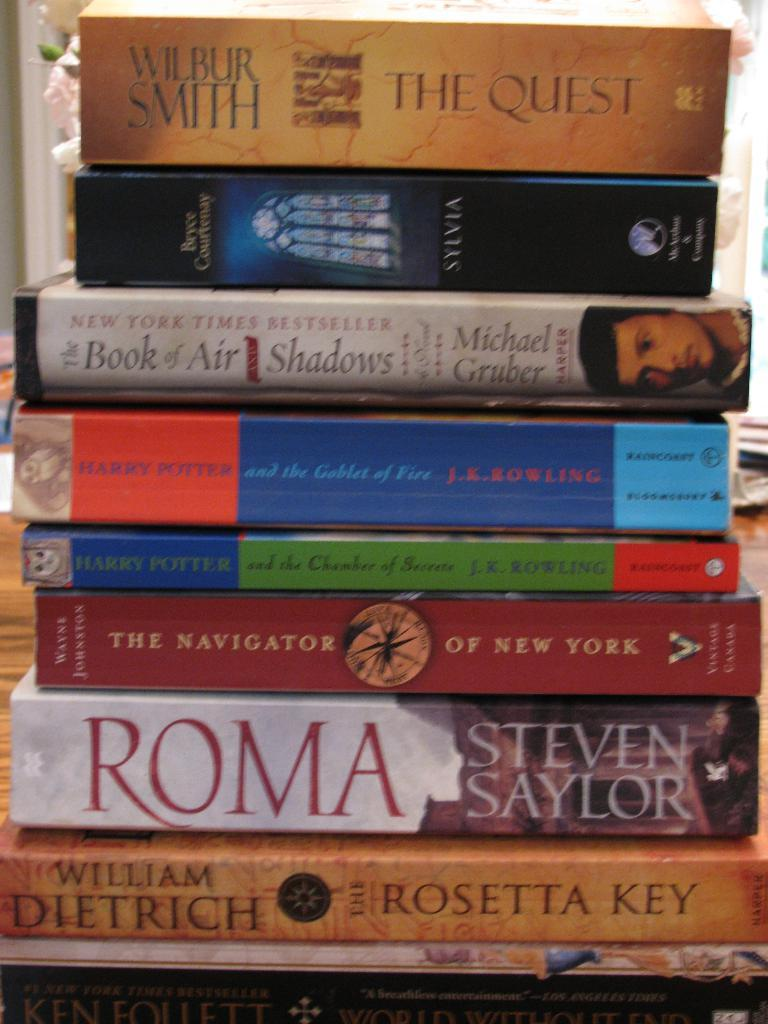<image>
Create a compact narrative representing the image presented. The book The Quest sits atop a stack of other books. 